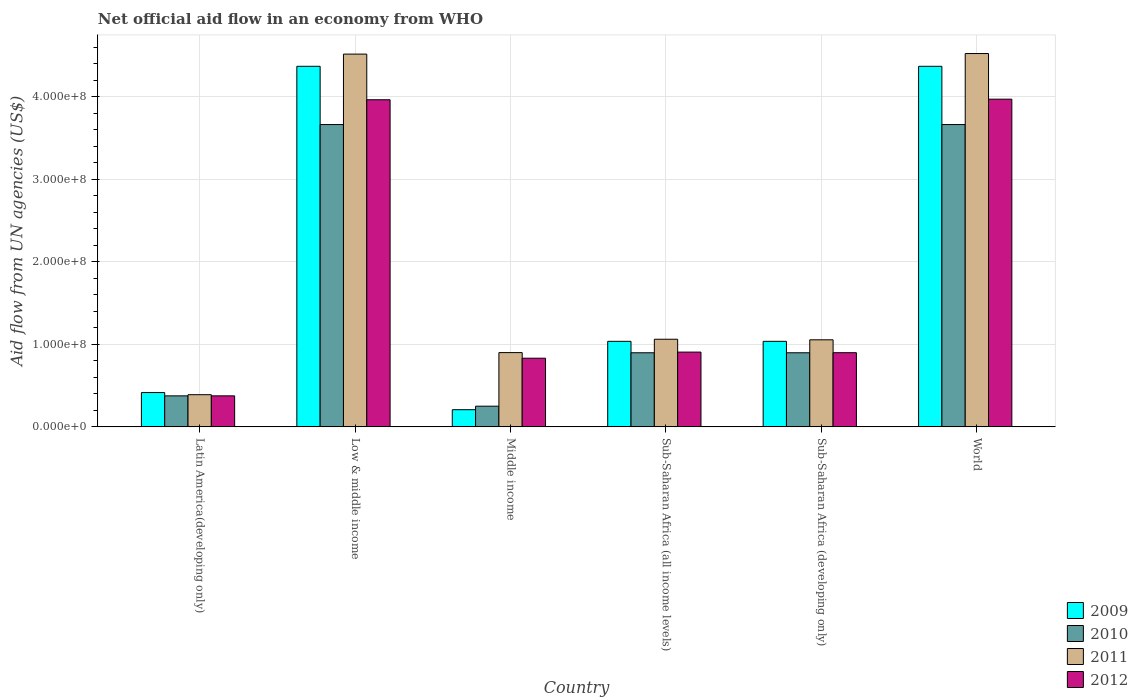How many different coloured bars are there?
Provide a short and direct response. 4. How many groups of bars are there?
Provide a succinct answer. 6. Are the number of bars on each tick of the X-axis equal?
Offer a very short reply. Yes. How many bars are there on the 4th tick from the left?
Make the answer very short. 4. In how many cases, is the number of bars for a given country not equal to the number of legend labels?
Give a very brief answer. 0. What is the net official aid flow in 2011 in Sub-Saharan Africa (developing only)?
Give a very brief answer. 1.05e+08. Across all countries, what is the maximum net official aid flow in 2009?
Give a very brief answer. 4.37e+08. Across all countries, what is the minimum net official aid flow in 2011?
Keep it short and to the point. 3.90e+07. In which country was the net official aid flow in 2011 maximum?
Offer a very short reply. World. In which country was the net official aid flow in 2010 minimum?
Offer a terse response. Middle income. What is the total net official aid flow in 2012 in the graph?
Give a very brief answer. 1.09e+09. What is the difference between the net official aid flow in 2012 in Latin America(developing only) and that in World?
Provide a succinct answer. -3.59e+08. What is the difference between the net official aid flow in 2012 in World and the net official aid flow in 2010 in Sub-Saharan Africa (developing only)?
Your answer should be very brief. 3.07e+08. What is the average net official aid flow in 2011 per country?
Offer a very short reply. 2.07e+08. What is the difference between the net official aid flow of/in 2009 and net official aid flow of/in 2012 in Sub-Saharan Africa (developing only)?
Your response must be concise. 1.38e+07. What is the ratio of the net official aid flow in 2012 in Latin America(developing only) to that in Sub-Saharan Africa (all income levels)?
Make the answer very short. 0.41. What is the difference between the highest and the second highest net official aid flow in 2012?
Ensure brevity in your answer.  3.06e+08. What is the difference between the highest and the lowest net official aid flow in 2010?
Your answer should be very brief. 3.41e+08. Is the sum of the net official aid flow in 2011 in Sub-Saharan Africa (developing only) and World greater than the maximum net official aid flow in 2012 across all countries?
Give a very brief answer. Yes. What does the 3rd bar from the left in Middle income represents?
Keep it short and to the point. 2011. What does the 1st bar from the right in Latin America(developing only) represents?
Make the answer very short. 2012. Is it the case that in every country, the sum of the net official aid flow in 2011 and net official aid flow in 2012 is greater than the net official aid flow in 2010?
Provide a succinct answer. Yes. How many countries are there in the graph?
Keep it short and to the point. 6. Are the values on the major ticks of Y-axis written in scientific E-notation?
Your answer should be very brief. Yes. What is the title of the graph?
Offer a very short reply. Net official aid flow in an economy from WHO. Does "1999" appear as one of the legend labels in the graph?
Provide a succinct answer. No. What is the label or title of the Y-axis?
Offer a very short reply. Aid flow from UN agencies (US$). What is the Aid flow from UN agencies (US$) in 2009 in Latin America(developing only)?
Give a very brief answer. 4.16e+07. What is the Aid flow from UN agencies (US$) in 2010 in Latin America(developing only)?
Provide a short and direct response. 3.76e+07. What is the Aid flow from UN agencies (US$) of 2011 in Latin America(developing only)?
Keep it short and to the point. 3.90e+07. What is the Aid flow from UN agencies (US$) in 2012 in Latin America(developing only)?
Provide a short and direct response. 3.76e+07. What is the Aid flow from UN agencies (US$) in 2009 in Low & middle income?
Keep it short and to the point. 4.37e+08. What is the Aid flow from UN agencies (US$) of 2010 in Low & middle income?
Make the answer very short. 3.66e+08. What is the Aid flow from UN agencies (US$) of 2011 in Low & middle income?
Your response must be concise. 4.52e+08. What is the Aid flow from UN agencies (US$) in 2012 in Low & middle income?
Ensure brevity in your answer.  3.96e+08. What is the Aid flow from UN agencies (US$) in 2009 in Middle income?
Your answer should be very brief. 2.08e+07. What is the Aid flow from UN agencies (US$) in 2010 in Middle income?
Offer a terse response. 2.51e+07. What is the Aid flow from UN agencies (US$) in 2011 in Middle income?
Offer a terse response. 9.00e+07. What is the Aid flow from UN agencies (US$) of 2012 in Middle income?
Your response must be concise. 8.32e+07. What is the Aid flow from UN agencies (US$) in 2009 in Sub-Saharan Africa (all income levels)?
Offer a very short reply. 1.04e+08. What is the Aid flow from UN agencies (US$) of 2010 in Sub-Saharan Africa (all income levels)?
Offer a very short reply. 8.98e+07. What is the Aid flow from UN agencies (US$) in 2011 in Sub-Saharan Africa (all income levels)?
Ensure brevity in your answer.  1.06e+08. What is the Aid flow from UN agencies (US$) in 2012 in Sub-Saharan Africa (all income levels)?
Your answer should be compact. 9.06e+07. What is the Aid flow from UN agencies (US$) of 2009 in Sub-Saharan Africa (developing only)?
Offer a terse response. 1.04e+08. What is the Aid flow from UN agencies (US$) of 2010 in Sub-Saharan Africa (developing only)?
Give a very brief answer. 8.98e+07. What is the Aid flow from UN agencies (US$) in 2011 in Sub-Saharan Africa (developing only)?
Make the answer very short. 1.05e+08. What is the Aid flow from UN agencies (US$) in 2012 in Sub-Saharan Africa (developing only)?
Make the answer very short. 8.98e+07. What is the Aid flow from UN agencies (US$) in 2009 in World?
Keep it short and to the point. 4.37e+08. What is the Aid flow from UN agencies (US$) in 2010 in World?
Provide a succinct answer. 3.66e+08. What is the Aid flow from UN agencies (US$) of 2011 in World?
Provide a succinct answer. 4.52e+08. What is the Aid flow from UN agencies (US$) of 2012 in World?
Make the answer very short. 3.97e+08. Across all countries, what is the maximum Aid flow from UN agencies (US$) in 2009?
Keep it short and to the point. 4.37e+08. Across all countries, what is the maximum Aid flow from UN agencies (US$) of 2010?
Ensure brevity in your answer.  3.66e+08. Across all countries, what is the maximum Aid flow from UN agencies (US$) in 2011?
Offer a very short reply. 4.52e+08. Across all countries, what is the maximum Aid flow from UN agencies (US$) of 2012?
Keep it short and to the point. 3.97e+08. Across all countries, what is the minimum Aid flow from UN agencies (US$) in 2009?
Offer a terse response. 2.08e+07. Across all countries, what is the minimum Aid flow from UN agencies (US$) in 2010?
Offer a terse response. 2.51e+07. Across all countries, what is the minimum Aid flow from UN agencies (US$) in 2011?
Your response must be concise. 3.90e+07. Across all countries, what is the minimum Aid flow from UN agencies (US$) in 2012?
Provide a succinct answer. 3.76e+07. What is the total Aid flow from UN agencies (US$) in 2009 in the graph?
Provide a short and direct response. 1.14e+09. What is the total Aid flow from UN agencies (US$) of 2010 in the graph?
Your response must be concise. 9.75e+08. What is the total Aid flow from UN agencies (US$) in 2011 in the graph?
Your response must be concise. 1.24e+09. What is the total Aid flow from UN agencies (US$) in 2012 in the graph?
Keep it short and to the point. 1.09e+09. What is the difference between the Aid flow from UN agencies (US$) of 2009 in Latin America(developing only) and that in Low & middle income?
Offer a terse response. -3.95e+08. What is the difference between the Aid flow from UN agencies (US$) in 2010 in Latin America(developing only) and that in Low & middle income?
Give a very brief answer. -3.29e+08. What is the difference between the Aid flow from UN agencies (US$) in 2011 in Latin America(developing only) and that in Low & middle income?
Your answer should be compact. -4.13e+08. What is the difference between the Aid flow from UN agencies (US$) of 2012 in Latin America(developing only) and that in Low & middle income?
Keep it short and to the point. -3.59e+08. What is the difference between the Aid flow from UN agencies (US$) in 2009 in Latin America(developing only) and that in Middle income?
Ensure brevity in your answer.  2.08e+07. What is the difference between the Aid flow from UN agencies (US$) in 2010 in Latin America(developing only) and that in Middle income?
Offer a terse response. 1.25e+07. What is the difference between the Aid flow from UN agencies (US$) in 2011 in Latin America(developing only) and that in Middle income?
Offer a very short reply. -5.10e+07. What is the difference between the Aid flow from UN agencies (US$) of 2012 in Latin America(developing only) and that in Middle income?
Your answer should be very brief. -4.56e+07. What is the difference between the Aid flow from UN agencies (US$) in 2009 in Latin America(developing only) and that in Sub-Saharan Africa (all income levels)?
Offer a terse response. -6.20e+07. What is the difference between the Aid flow from UN agencies (US$) of 2010 in Latin America(developing only) and that in Sub-Saharan Africa (all income levels)?
Give a very brief answer. -5.22e+07. What is the difference between the Aid flow from UN agencies (US$) of 2011 in Latin America(developing only) and that in Sub-Saharan Africa (all income levels)?
Give a very brief answer. -6.72e+07. What is the difference between the Aid flow from UN agencies (US$) in 2012 in Latin America(developing only) and that in Sub-Saharan Africa (all income levels)?
Provide a succinct answer. -5.30e+07. What is the difference between the Aid flow from UN agencies (US$) in 2009 in Latin America(developing only) and that in Sub-Saharan Africa (developing only)?
Ensure brevity in your answer.  -6.20e+07. What is the difference between the Aid flow from UN agencies (US$) in 2010 in Latin America(developing only) and that in Sub-Saharan Africa (developing only)?
Provide a short and direct response. -5.22e+07. What is the difference between the Aid flow from UN agencies (US$) in 2011 in Latin America(developing only) and that in Sub-Saharan Africa (developing only)?
Your answer should be very brief. -6.65e+07. What is the difference between the Aid flow from UN agencies (US$) of 2012 in Latin America(developing only) and that in Sub-Saharan Africa (developing only)?
Provide a short and direct response. -5.23e+07. What is the difference between the Aid flow from UN agencies (US$) in 2009 in Latin America(developing only) and that in World?
Your answer should be very brief. -3.95e+08. What is the difference between the Aid flow from UN agencies (US$) in 2010 in Latin America(developing only) and that in World?
Provide a short and direct response. -3.29e+08. What is the difference between the Aid flow from UN agencies (US$) of 2011 in Latin America(developing only) and that in World?
Your answer should be compact. -4.13e+08. What is the difference between the Aid flow from UN agencies (US$) in 2012 in Latin America(developing only) and that in World?
Your response must be concise. -3.59e+08. What is the difference between the Aid flow from UN agencies (US$) in 2009 in Low & middle income and that in Middle income?
Provide a short and direct response. 4.16e+08. What is the difference between the Aid flow from UN agencies (US$) of 2010 in Low & middle income and that in Middle income?
Your answer should be compact. 3.41e+08. What is the difference between the Aid flow from UN agencies (US$) of 2011 in Low & middle income and that in Middle income?
Provide a short and direct response. 3.62e+08. What is the difference between the Aid flow from UN agencies (US$) in 2012 in Low & middle income and that in Middle income?
Provide a short and direct response. 3.13e+08. What is the difference between the Aid flow from UN agencies (US$) in 2009 in Low & middle income and that in Sub-Saharan Africa (all income levels)?
Provide a short and direct response. 3.33e+08. What is the difference between the Aid flow from UN agencies (US$) in 2010 in Low & middle income and that in Sub-Saharan Africa (all income levels)?
Keep it short and to the point. 2.76e+08. What is the difference between the Aid flow from UN agencies (US$) of 2011 in Low & middle income and that in Sub-Saharan Africa (all income levels)?
Ensure brevity in your answer.  3.45e+08. What is the difference between the Aid flow from UN agencies (US$) of 2012 in Low & middle income and that in Sub-Saharan Africa (all income levels)?
Provide a succinct answer. 3.06e+08. What is the difference between the Aid flow from UN agencies (US$) in 2009 in Low & middle income and that in Sub-Saharan Africa (developing only)?
Provide a succinct answer. 3.33e+08. What is the difference between the Aid flow from UN agencies (US$) of 2010 in Low & middle income and that in Sub-Saharan Africa (developing only)?
Your response must be concise. 2.76e+08. What is the difference between the Aid flow from UN agencies (US$) in 2011 in Low & middle income and that in Sub-Saharan Africa (developing only)?
Provide a succinct answer. 3.46e+08. What is the difference between the Aid flow from UN agencies (US$) of 2012 in Low & middle income and that in Sub-Saharan Africa (developing only)?
Your response must be concise. 3.06e+08. What is the difference between the Aid flow from UN agencies (US$) in 2009 in Low & middle income and that in World?
Your answer should be compact. 0. What is the difference between the Aid flow from UN agencies (US$) of 2010 in Low & middle income and that in World?
Ensure brevity in your answer.  0. What is the difference between the Aid flow from UN agencies (US$) in 2011 in Low & middle income and that in World?
Offer a very short reply. -6.70e+05. What is the difference between the Aid flow from UN agencies (US$) of 2012 in Low & middle income and that in World?
Give a very brief answer. -7.20e+05. What is the difference between the Aid flow from UN agencies (US$) in 2009 in Middle income and that in Sub-Saharan Africa (all income levels)?
Your response must be concise. -8.28e+07. What is the difference between the Aid flow from UN agencies (US$) in 2010 in Middle income and that in Sub-Saharan Africa (all income levels)?
Keep it short and to the point. -6.47e+07. What is the difference between the Aid flow from UN agencies (US$) of 2011 in Middle income and that in Sub-Saharan Africa (all income levels)?
Your answer should be very brief. -1.62e+07. What is the difference between the Aid flow from UN agencies (US$) of 2012 in Middle income and that in Sub-Saharan Africa (all income levels)?
Your answer should be very brief. -7.39e+06. What is the difference between the Aid flow from UN agencies (US$) in 2009 in Middle income and that in Sub-Saharan Africa (developing only)?
Give a very brief answer. -8.28e+07. What is the difference between the Aid flow from UN agencies (US$) of 2010 in Middle income and that in Sub-Saharan Africa (developing only)?
Offer a very short reply. -6.47e+07. What is the difference between the Aid flow from UN agencies (US$) of 2011 in Middle income and that in Sub-Saharan Africa (developing only)?
Your response must be concise. -1.55e+07. What is the difference between the Aid flow from UN agencies (US$) of 2012 in Middle income and that in Sub-Saharan Africa (developing only)?
Your answer should be compact. -6.67e+06. What is the difference between the Aid flow from UN agencies (US$) in 2009 in Middle income and that in World?
Give a very brief answer. -4.16e+08. What is the difference between the Aid flow from UN agencies (US$) of 2010 in Middle income and that in World?
Your answer should be compact. -3.41e+08. What is the difference between the Aid flow from UN agencies (US$) of 2011 in Middle income and that in World?
Provide a succinct answer. -3.62e+08. What is the difference between the Aid flow from UN agencies (US$) of 2012 in Middle income and that in World?
Make the answer very short. -3.14e+08. What is the difference between the Aid flow from UN agencies (US$) in 2009 in Sub-Saharan Africa (all income levels) and that in Sub-Saharan Africa (developing only)?
Provide a short and direct response. 0. What is the difference between the Aid flow from UN agencies (US$) in 2011 in Sub-Saharan Africa (all income levels) and that in Sub-Saharan Africa (developing only)?
Provide a short and direct response. 6.70e+05. What is the difference between the Aid flow from UN agencies (US$) in 2012 in Sub-Saharan Africa (all income levels) and that in Sub-Saharan Africa (developing only)?
Ensure brevity in your answer.  7.20e+05. What is the difference between the Aid flow from UN agencies (US$) in 2009 in Sub-Saharan Africa (all income levels) and that in World?
Your response must be concise. -3.33e+08. What is the difference between the Aid flow from UN agencies (US$) of 2010 in Sub-Saharan Africa (all income levels) and that in World?
Ensure brevity in your answer.  -2.76e+08. What is the difference between the Aid flow from UN agencies (US$) of 2011 in Sub-Saharan Africa (all income levels) and that in World?
Your response must be concise. -3.46e+08. What is the difference between the Aid flow from UN agencies (US$) of 2012 in Sub-Saharan Africa (all income levels) and that in World?
Provide a short and direct response. -3.06e+08. What is the difference between the Aid flow from UN agencies (US$) of 2009 in Sub-Saharan Africa (developing only) and that in World?
Your response must be concise. -3.33e+08. What is the difference between the Aid flow from UN agencies (US$) of 2010 in Sub-Saharan Africa (developing only) and that in World?
Give a very brief answer. -2.76e+08. What is the difference between the Aid flow from UN agencies (US$) of 2011 in Sub-Saharan Africa (developing only) and that in World?
Your answer should be very brief. -3.47e+08. What is the difference between the Aid flow from UN agencies (US$) of 2012 in Sub-Saharan Africa (developing only) and that in World?
Give a very brief answer. -3.07e+08. What is the difference between the Aid flow from UN agencies (US$) of 2009 in Latin America(developing only) and the Aid flow from UN agencies (US$) of 2010 in Low & middle income?
Provide a succinct answer. -3.25e+08. What is the difference between the Aid flow from UN agencies (US$) in 2009 in Latin America(developing only) and the Aid flow from UN agencies (US$) in 2011 in Low & middle income?
Your answer should be compact. -4.10e+08. What is the difference between the Aid flow from UN agencies (US$) in 2009 in Latin America(developing only) and the Aid flow from UN agencies (US$) in 2012 in Low & middle income?
Your answer should be very brief. -3.55e+08. What is the difference between the Aid flow from UN agencies (US$) in 2010 in Latin America(developing only) and the Aid flow from UN agencies (US$) in 2011 in Low & middle income?
Give a very brief answer. -4.14e+08. What is the difference between the Aid flow from UN agencies (US$) in 2010 in Latin America(developing only) and the Aid flow from UN agencies (US$) in 2012 in Low & middle income?
Your answer should be compact. -3.59e+08. What is the difference between the Aid flow from UN agencies (US$) of 2011 in Latin America(developing only) and the Aid flow from UN agencies (US$) of 2012 in Low & middle income?
Make the answer very short. -3.57e+08. What is the difference between the Aid flow from UN agencies (US$) of 2009 in Latin America(developing only) and the Aid flow from UN agencies (US$) of 2010 in Middle income?
Offer a very short reply. 1.65e+07. What is the difference between the Aid flow from UN agencies (US$) of 2009 in Latin America(developing only) and the Aid flow from UN agencies (US$) of 2011 in Middle income?
Keep it short and to the point. -4.84e+07. What is the difference between the Aid flow from UN agencies (US$) of 2009 in Latin America(developing only) and the Aid flow from UN agencies (US$) of 2012 in Middle income?
Your answer should be very brief. -4.16e+07. What is the difference between the Aid flow from UN agencies (US$) in 2010 in Latin America(developing only) and the Aid flow from UN agencies (US$) in 2011 in Middle income?
Ensure brevity in your answer.  -5.24e+07. What is the difference between the Aid flow from UN agencies (US$) of 2010 in Latin America(developing only) and the Aid flow from UN agencies (US$) of 2012 in Middle income?
Make the answer very short. -4.56e+07. What is the difference between the Aid flow from UN agencies (US$) of 2011 in Latin America(developing only) and the Aid flow from UN agencies (US$) of 2012 in Middle income?
Keep it short and to the point. -4.42e+07. What is the difference between the Aid flow from UN agencies (US$) in 2009 in Latin America(developing only) and the Aid flow from UN agencies (US$) in 2010 in Sub-Saharan Africa (all income levels)?
Your response must be concise. -4.82e+07. What is the difference between the Aid flow from UN agencies (US$) of 2009 in Latin America(developing only) and the Aid flow from UN agencies (US$) of 2011 in Sub-Saharan Africa (all income levels)?
Keep it short and to the point. -6.46e+07. What is the difference between the Aid flow from UN agencies (US$) of 2009 in Latin America(developing only) and the Aid flow from UN agencies (US$) of 2012 in Sub-Saharan Africa (all income levels)?
Offer a terse response. -4.90e+07. What is the difference between the Aid flow from UN agencies (US$) in 2010 in Latin America(developing only) and the Aid flow from UN agencies (US$) in 2011 in Sub-Saharan Africa (all income levels)?
Your response must be concise. -6.86e+07. What is the difference between the Aid flow from UN agencies (US$) in 2010 in Latin America(developing only) and the Aid flow from UN agencies (US$) in 2012 in Sub-Saharan Africa (all income levels)?
Offer a very short reply. -5.30e+07. What is the difference between the Aid flow from UN agencies (US$) in 2011 in Latin America(developing only) and the Aid flow from UN agencies (US$) in 2012 in Sub-Saharan Africa (all income levels)?
Give a very brief answer. -5.16e+07. What is the difference between the Aid flow from UN agencies (US$) of 2009 in Latin America(developing only) and the Aid flow from UN agencies (US$) of 2010 in Sub-Saharan Africa (developing only)?
Keep it short and to the point. -4.82e+07. What is the difference between the Aid flow from UN agencies (US$) in 2009 in Latin America(developing only) and the Aid flow from UN agencies (US$) in 2011 in Sub-Saharan Africa (developing only)?
Make the answer very short. -6.39e+07. What is the difference between the Aid flow from UN agencies (US$) in 2009 in Latin America(developing only) and the Aid flow from UN agencies (US$) in 2012 in Sub-Saharan Africa (developing only)?
Keep it short and to the point. -4.83e+07. What is the difference between the Aid flow from UN agencies (US$) of 2010 in Latin America(developing only) and the Aid flow from UN agencies (US$) of 2011 in Sub-Saharan Africa (developing only)?
Offer a terse response. -6.79e+07. What is the difference between the Aid flow from UN agencies (US$) in 2010 in Latin America(developing only) and the Aid flow from UN agencies (US$) in 2012 in Sub-Saharan Africa (developing only)?
Give a very brief answer. -5.23e+07. What is the difference between the Aid flow from UN agencies (US$) in 2011 in Latin America(developing only) and the Aid flow from UN agencies (US$) in 2012 in Sub-Saharan Africa (developing only)?
Make the answer very short. -5.09e+07. What is the difference between the Aid flow from UN agencies (US$) in 2009 in Latin America(developing only) and the Aid flow from UN agencies (US$) in 2010 in World?
Provide a short and direct response. -3.25e+08. What is the difference between the Aid flow from UN agencies (US$) of 2009 in Latin America(developing only) and the Aid flow from UN agencies (US$) of 2011 in World?
Your answer should be compact. -4.11e+08. What is the difference between the Aid flow from UN agencies (US$) of 2009 in Latin America(developing only) and the Aid flow from UN agencies (US$) of 2012 in World?
Offer a very short reply. -3.55e+08. What is the difference between the Aid flow from UN agencies (US$) of 2010 in Latin America(developing only) and the Aid flow from UN agencies (US$) of 2011 in World?
Offer a terse response. -4.15e+08. What is the difference between the Aid flow from UN agencies (US$) in 2010 in Latin America(developing only) and the Aid flow from UN agencies (US$) in 2012 in World?
Offer a very short reply. -3.59e+08. What is the difference between the Aid flow from UN agencies (US$) of 2011 in Latin America(developing only) and the Aid flow from UN agencies (US$) of 2012 in World?
Offer a terse response. -3.58e+08. What is the difference between the Aid flow from UN agencies (US$) of 2009 in Low & middle income and the Aid flow from UN agencies (US$) of 2010 in Middle income?
Your answer should be compact. 4.12e+08. What is the difference between the Aid flow from UN agencies (US$) of 2009 in Low & middle income and the Aid flow from UN agencies (US$) of 2011 in Middle income?
Your response must be concise. 3.47e+08. What is the difference between the Aid flow from UN agencies (US$) in 2009 in Low & middle income and the Aid flow from UN agencies (US$) in 2012 in Middle income?
Provide a succinct answer. 3.54e+08. What is the difference between the Aid flow from UN agencies (US$) in 2010 in Low & middle income and the Aid flow from UN agencies (US$) in 2011 in Middle income?
Make the answer very short. 2.76e+08. What is the difference between the Aid flow from UN agencies (US$) of 2010 in Low & middle income and the Aid flow from UN agencies (US$) of 2012 in Middle income?
Ensure brevity in your answer.  2.83e+08. What is the difference between the Aid flow from UN agencies (US$) of 2011 in Low & middle income and the Aid flow from UN agencies (US$) of 2012 in Middle income?
Offer a terse response. 3.68e+08. What is the difference between the Aid flow from UN agencies (US$) in 2009 in Low & middle income and the Aid flow from UN agencies (US$) in 2010 in Sub-Saharan Africa (all income levels)?
Make the answer very short. 3.47e+08. What is the difference between the Aid flow from UN agencies (US$) of 2009 in Low & middle income and the Aid flow from UN agencies (US$) of 2011 in Sub-Saharan Africa (all income levels)?
Ensure brevity in your answer.  3.31e+08. What is the difference between the Aid flow from UN agencies (US$) in 2009 in Low & middle income and the Aid flow from UN agencies (US$) in 2012 in Sub-Saharan Africa (all income levels)?
Ensure brevity in your answer.  3.46e+08. What is the difference between the Aid flow from UN agencies (US$) in 2010 in Low & middle income and the Aid flow from UN agencies (US$) in 2011 in Sub-Saharan Africa (all income levels)?
Your answer should be very brief. 2.60e+08. What is the difference between the Aid flow from UN agencies (US$) of 2010 in Low & middle income and the Aid flow from UN agencies (US$) of 2012 in Sub-Saharan Africa (all income levels)?
Give a very brief answer. 2.76e+08. What is the difference between the Aid flow from UN agencies (US$) of 2011 in Low & middle income and the Aid flow from UN agencies (US$) of 2012 in Sub-Saharan Africa (all income levels)?
Ensure brevity in your answer.  3.61e+08. What is the difference between the Aid flow from UN agencies (US$) in 2009 in Low & middle income and the Aid flow from UN agencies (US$) in 2010 in Sub-Saharan Africa (developing only)?
Provide a short and direct response. 3.47e+08. What is the difference between the Aid flow from UN agencies (US$) of 2009 in Low & middle income and the Aid flow from UN agencies (US$) of 2011 in Sub-Saharan Africa (developing only)?
Keep it short and to the point. 3.31e+08. What is the difference between the Aid flow from UN agencies (US$) in 2009 in Low & middle income and the Aid flow from UN agencies (US$) in 2012 in Sub-Saharan Africa (developing only)?
Make the answer very short. 3.47e+08. What is the difference between the Aid flow from UN agencies (US$) in 2010 in Low & middle income and the Aid flow from UN agencies (US$) in 2011 in Sub-Saharan Africa (developing only)?
Ensure brevity in your answer.  2.61e+08. What is the difference between the Aid flow from UN agencies (US$) in 2010 in Low & middle income and the Aid flow from UN agencies (US$) in 2012 in Sub-Saharan Africa (developing only)?
Offer a very short reply. 2.76e+08. What is the difference between the Aid flow from UN agencies (US$) of 2011 in Low & middle income and the Aid flow from UN agencies (US$) of 2012 in Sub-Saharan Africa (developing only)?
Ensure brevity in your answer.  3.62e+08. What is the difference between the Aid flow from UN agencies (US$) of 2009 in Low & middle income and the Aid flow from UN agencies (US$) of 2010 in World?
Offer a terse response. 7.06e+07. What is the difference between the Aid flow from UN agencies (US$) of 2009 in Low & middle income and the Aid flow from UN agencies (US$) of 2011 in World?
Your answer should be very brief. -1.55e+07. What is the difference between the Aid flow from UN agencies (US$) in 2009 in Low & middle income and the Aid flow from UN agencies (US$) in 2012 in World?
Provide a succinct answer. 3.98e+07. What is the difference between the Aid flow from UN agencies (US$) of 2010 in Low & middle income and the Aid flow from UN agencies (US$) of 2011 in World?
Your answer should be very brief. -8.60e+07. What is the difference between the Aid flow from UN agencies (US$) in 2010 in Low & middle income and the Aid flow from UN agencies (US$) in 2012 in World?
Your answer should be very brief. -3.08e+07. What is the difference between the Aid flow from UN agencies (US$) in 2011 in Low & middle income and the Aid flow from UN agencies (US$) in 2012 in World?
Ensure brevity in your answer.  5.46e+07. What is the difference between the Aid flow from UN agencies (US$) of 2009 in Middle income and the Aid flow from UN agencies (US$) of 2010 in Sub-Saharan Africa (all income levels)?
Provide a succinct answer. -6.90e+07. What is the difference between the Aid flow from UN agencies (US$) of 2009 in Middle income and the Aid flow from UN agencies (US$) of 2011 in Sub-Saharan Africa (all income levels)?
Provide a succinct answer. -8.54e+07. What is the difference between the Aid flow from UN agencies (US$) of 2009 in Middle income and the Aid flow from UN agencies (US$) of 2012 in Sub-Saharan Africa (all income levels)?
Keep it short and to the point. -6.98e+07. What is the difference between the Aid flow from UN agencies (US$) of 2010 in Middle income and the Aid flow from UN agencies (US$) of 2011 in Sub-Saharan Africa (all income levels)?
Make the answer very short. -8.11e+07. What is the difference between the Aid flow from UN agencies (US$) of 2010 in Middle income and the Aid flow from UN agencies (US$) of 2012 in Sub-Saharan Africa (all income levels)?
Keep it short and to the point. -6.55e+07. What is the difference between the Aid flow from UN agencies (US$) of 2011 in Middle income and the Aid flow from UN agencies (US$) of 2012 in Sub-Saharan Africa (all income levels)?
Keep it short and to the point. -5.90e+05. What is the difference between the Aid flow from UN agencies (US$) in 2009 in Middle income and the Aid flow from UN agencies (US$) in 2010 in Sub-Saharan Africa (developing only)?
Keep it short and to the point. -6.90e+07. What is the difference between the Aid flow from UN agencies (US$) in 2009 in Middle income and the Aid flow from UN agencies (US$) in 2011 in Sub-Saharan Africa (developing only)?
Your response must be concise. -8.47e+07. What is the difference between the Aid flow from UN agencies (US$) of 2009 in Middle income and the Aid flow from UN agencies (US$) of 2012 in Sub-Saharan Africa (developing only)?
Keep it short and to the point. -6.90e+07. What is the difference between the Aid flow from UN agencies (US$) of 2010 in Middle income and the Aid flow from UN agencies (US$) of 2011 in Sub-Saharan Africa (developing only)?
Offer a very short reply. -8.04e+07. What is the difference between the Aid flow from UN agencies (US$) of 2010 in Middle income and the Aid flow from UN agencies (US$) of 2012 in Sub-Saharan Africa (developing only)?
Your answer should be compact. -6.48e+07. What is the difference between the Aid flow from UN agencies (US$) of 2009 in Middle income and the Aid flow from UN agencies (US$) of 2010 in World?
Make the answer very short. -3.45e+08. What is the difference between the Aid flow from UN agencies (US$) of 2009 in Middle income and the Aid flow from UN agencies (US$) of 2011 in World?
Offer a very short reply. -4.31e+08. What is the difference between the Aid flow from UN agencies (US$) of 2009 in Middle income and the Aid flow from UN agencies (US$) of 2012 in World?
Provide a short and direct response. -3.76e+08. What is the difference between the Aid flow from UN agencies (US$) of 2010 in Middle income and the Aid flow from UN agencies (US$) of 2011 in World?
Provide a short and direct response. -4.27e+08. What is the difference between the Aid flow from UN agencies (US$) in 2010 in Middle income and the Aid flow from UN agencies (US$) in 2012 in World?
Offer a very short reply. -3.72e+08. What is the difference between the Aid flow from UN agencies (US$) in 2011 in Middle income and the Aid flow from UN agencies (US$) in 2012 in World?
Give a very brief answer. -3.07e+08. What is the difference between the Aid flow from UN agencies (US$) of 2009 in Sub-Saharan Africa (all income levels) and the Aid flow from UN agencies (US$) of 2010 in Sub-Saharan Africa (developing only)?
Keep it short and to the point. 1.39e+07. What is the difference between the Aid flow from UN agencies (US$) of 2009 in Sub-Saharan Africa (all income levels) and the Aid flow from UN agencies (US$) of 2011 in Sub-Saharan Africa (developing only)?
Your response must be concise. -1.86e+06. What is the difference between the Aid flow from UN agencies (US$) in 2009 in Sub-Saharan Africa (all income levels) and the Aid flow from UN agencies (US$) in 2012 in Sub-Saharan Africa (developing only)?
Keep it short and to the point. 1.38e+07. What is the difference between the Aid flow from UN agencies (US$) in 2010 in Sub-Saharan Africa (all income levels) and the Aid flow from UN agencies (US$) in 2011 in Sub-Saharan Africa (developing only)?
Your response must be concise. -1.57e+07. What is the difference between the Aid flow from UN agencies (US$) of 2011 in Sub-Saharan Africa (all income levels) and the Aid flow from UN agencies (US$) of 2012 in Sub-Saharan Africa (developing only)?
Your answer should be compact. 1.63e+07. What is the difference between the Aid flow from UN agencies (US$) in 2009 in Sub-Saharan Africa (all income levels) and the Aid flow from UN agencies (US$) in 2010 in World?
Give a very brief answer. -2.63e+08. What is the difference between the Aid flow from UN agencies (US$) of 2009 in Sub-Saharan Africa (all income levels) and the Aid flow from UN agencies (US$) of 2011 in World?
Ensure brevity in your answer.  -3.49e+08. What is the difference between the Aid flow from UN agencies (US$) of 2009 in Sub-Saharan Africa (all income levels) and the Aid flow from UN agencies (US$) of 2012 in World?
Make the answer very short. -2.93e+08. What is the difference between the Aid flow from UN agencies (US$) of 2010 in Sub-Saharan Africa (all income levels) and the Aid flow from UN agencies (US$) of 2011 in World?
Provide a short and direct response. -3.62e+08. What is the difference between the Aid flow from UN agencies (US$) in 2010 in Sub-Saharan Africa (all income levels) and the Aid flow from UN agencies (US$) in 2012 in World?
Your answer should be compact. -3.07e+08. What is the difference between the Aid flow from UN agencies (US$) of 2011 in Sub-Saharan Africa (all income levels) and the Aid flow from UN agencies (US$) of 2012 in World?
Your answer should be very brief. -2.91e+08. What is the difference between the Aid flow from UN agencies (US$) in 2009 in Sub-Saharan Africa (developing only) and the Aid flow from UN agencies (US$) in 2010 in World?
Provide a short and direct response. -2.63e+08. What is the difference between the Aid flow from UN agencies (US$) of 2009 in Sub-Saharan Africa (developing only) and the Aid flow from UN agencies (US$) of 2011 in World?
Make the answer very short. -3.49e+08. What is the difference between the Aid flow from UN agencies (US$) of 2009 in Sub-Saharan Africa (developing only) and the Aid flow from UN agencies (US$) of 2012 in World?
Provide a short and direct response. -2.93e+08. What is the difference between the Aid flow from UN agencies (US$) of 2010 in Sub-Saharan Africa (developing only) and the Aid flow from UN agencies (US$) of 2011 in World?
Offer a terse response. -3.62e+08. What is the difference between the Aid flow from UN agencies (US$) of 2010 in Sub-Saharan Africa (developing only) and the Aid flow from UN agencies (US$) of 2012 in World?
Make the answer very short. -3.07e+08. What is the difference between the Aid flow from UN agencies (US$) in 2011 in Sub-Saharan Africa (developing only) and the Aid flow from UN agencies (US$) in 2012 in World?
Give a very brief answer. -2.92e+08. What is the average Aid flow from UN agencies (US$) of 2009 per country?
Ensure brevity in your answer.  1.91e+08. What is the average Aid flow from UN agencies (US$) of 2010 per country?
Give a very brief answer. 1.62e+08. What is the average Aid flow from UN agencies (US$) in 2011 per country?
Your answer should be very brief. 2.07e+08. What is the average Aid flow from UN agencies (US$) of 2012 per country?
Offer a terse response. 1.82e+08. What is the difference between the Aid flow from UN agencies (US$) in 2009 and Aid flow from UN agencies (US$) in 2010 in Latin America(developing only)?
Your answer should be very brief. 4.01e+06. What is the difference between the Aid flow from UN agencies (US$) in 2009 and Aid flow from UN agencies (US$) in 2011 in Latin America(developing only)?
Your answer should be compact. 2.59e+06. What is the difference between the Aid flow from UN agencies (US$) in 2009 and Aid flow from UN agencies (US$) in 2012 in Latin America(developing only)?
Your answer should be very brief. 3.99e+06. What is the difference between the Aid flow from UN agencies (US$) in 2010 and Aid flow from UN agencies (US$) in 2011 in Latin America(developing only)?
Offer a terse response. -1.42e+06. What is the difference between the Aid flow from UN agencies (US$) in 2010 and Aid flow from UN agencies (US$) in 2012 in Latin America(developing only)?
Your answer should be compact. -2.00e+04. What is the difference between the Aid flow from UN agencies (US$) of 2011 and Aid flow from UN agencies (US$) of 2012 in Latin America(developing only)?
Offer a terse response. 1.40e+06. What is the difference between the Aid flow from UN agencies (US$) in 2009 and Aid flow from UN agencies (US$) in 2010 in Low & middle income?
Ensure brevity in your answer.  7.06e+07. What is the difference between the Aid flow from UN agencies (US$) in 2009 and Aid flow from UN agencies (US$) in 2011 in Low & middle income?
Provide a succinct answer. -1.48e+07. What is the difference between the Aid flow from UN agencies (US$) of 2009 and Aid flow from UN agencies (US$) of 2012 in Low & middle income?
Ensure brevity in your answer.  4.05e+07. What is the difference between the Aid flow from UN agencies (US$) of 2010 and Aid flow from UN agencies (US$) of 2011 in Low & middle income?
Give a very brief answer. -8.54e+07. What is the difference between the Aid flow from UN agencies (US$) of 2010 and Aid flow from UN agencies (US$) of 2012 in Low & middle income?
Your answer should be compact. -3.00e+07. What is the difference between the Aid flow from UN agencies (US$) of 2011 and Aid flow from UN agencies (US$) of 2012 in Low & middle income?
Offer a terse response. 5.53e+07. What is the difference between the Aid flow from UN agencies (US$) in 2009 and Aid flow from UN agencies (US$) in 2010 in Middle income?
Provide a short and direct response. -4.27e+06. What is the difference between the Aid flow from UN agencies (US$) of 2009 and Aid flow from UN agencies (US$) of 2011 in Middle income?
Provide a short and direct response. -6.92e+07. What is the difference between the Aid flow from UN agencies (US$) of 2009 and Aid flow from UN agencies (US$) of 2012 in Middle income?
Your response must be concise. -6.24e+07. What is the difference between the Aid flow from UN agencies (US$) in 2010 and Aid flow from UN agencies (US$) in 2011 in Middle income?
Ensure brevity in your answer.  -6.49e+07. What is the difference between the Aid flow from UN agencies (US$) in 2010 and Aid flow from UN agencies (US$) in 2012 in Middle income?
Provide a succinct answer. -5.81e+07. What is the difference between the Aid flow from UN agencies (US$) of 2011 and Aid flow from UN agencies (US$) of 2012 in Middle income?
Keep it short and to the point. 6.80e+06. What is the difference between the Aid flow from UN agencies (US$) of 2009 and Aid flow from UN agencies (US$) of 2010 in Sub-Saharan Africa (all income levels)?
Your answer should be compact. 1.39e+07. What is the difference between the Aid flow from UN agencies (US$) of 2009 and Aid flow from UN agencies (US$) of 2011 in Sub-Saharan Africa (all income levels)?
Your response must be concise. -2.53e+06. What is the difference between the Aid flow from UN agencies (US$) of 2009 and Aid flow from UN agencies (US$) of 2012 in Sub-Saharan Africa (all income levels)?
Ensure brevity in your answer.  1.30e+07. What is the difference between the Aid flow from UN agencies (US$) in 2010 and Aid flow from UN agencies (US$) in 2011 in Sub-Saharan Africa (all income levels)?
Your answer should be compact. -1.64e+07. What is the difference between the Aid flow from UN agencies (US$) of 2010 and Aid flow from UN agencies (US$) of 2012 in Sub-Saharan Africa (all income levels)?
Your answer should be very brief. -8.10e+05. What is the difference between the Aid flow from UN agencies (US$) of 2011 and Aid flow from UN agencies (US$) of 2012 in Sub-Saharan Africa (all income levels)?
Your response must be concise. 1.56e+07. What is the difference between the Aid flow from UN agencies (US$) of 2009 and Aid flow from UN agencies (US$) of 2010 in Sub-Saharan Africa (developing only)?
Your answer should be compact. 1.39e+07. What is the difference between the Aid flow from UN agencies (US$) in 2009 and Aid flow from UN agencies (US$) in 2011 in Sub-Saharan Africa (developing only)?
Ensure brevity in your answer.  -1.86e+06. What is the difference between the Aid flow from UN agencies (US$) in 2009 and Aid flow from UN agencies (US$) in 2012 in Sub-Saharan Africa (developing only)?
Provide a succinct answer. 1.38e+07. What is the difference between the Aid flow from UN agencies (US$) in 2010 and Aid flow from UN agencies (US$) in 2011 in Sub-Saharan Africa (developing only)?
Your answer should be compact. -1.57e+07. What is the difference between the Aid flow from UN agencies (US$) of 2011 and Aid flow from UN agencies (US$) of 2012 in Sub-Saharan Africa (developing only)?
Provide a succinct answer. 1.56e+07. What is the difference between the Aid flow from UN agencies (US$) in 2009 and Aid flow from UN agencies (US$) in 2010 in World?
Make the answer very short. 7.06e+07. What is the difference between the Aid flow from UN agencies (US$) of 2009 and Aid flow from UN agencies (US$) of 2011 in World?
Your answer should be compact. -1.55e+07. What is the difference between the Aid flow from UN agencies (US$) of 2009 and Aid flow from UN agencies (US$) of 2012 in World?
Give a very brief answer. 3.98e+07. What is the difference between the Aid flow from UN agencies (US$) in 2010 and Aid flow from UN agencies (US$) in 2011 in World?
Your answer should be very brief. -8.60e+07. What is the difference between the Aid flow from UN agencies (US$) in 2010 and Aid flow from UN agencies (US$) in 2012 in World?
Your answer should be compact. -3.08e+07. What is the difference between the Aid flow from UN agencies (US$) of 2011 and Aid flow from UN agencies (US$) of 2012 in World?
Provide a short and direct response. 5.53e+07. What is the ratio of the Aid flow from UN agencies (US$) of 2009 in Latin America(developing only) to that in Low & middle income?
Make the answer very short. 0.1. What is the ratio of the Aid flow from UN agencies (US$) in 2010 in Latin America(developing only) to that in Low & middle income?
Give a very brief answer. 0.1. What is the ratio of the Aid flow from UN agencies (US$) in 2011 in Latin America(developing only) to that in Low & middle income?
Offer a very short reply. 0.09. What is the ratio of the Aid flow from UN agencies (US$) in 2012 in Latin America(developing only) to that in Low & middle income?
Provide a succinct answer. 0.09. What is the ratio of the Aid flow from UN agencies (US$) of 2009 in Latin America(developing only) to that in Middle income?
Offer a terse response. 2. What is the ratio of the Aid flow from UN agencies (US$) in 2010 in Latin America(developing only) to that in Middle income?
Offer a terse response. 1.5. What is the ratio of the Aid flow from UN agencies (US$) in 2011 in Latin America(developing only) to that in Middle income?
Make the answer very short. 0.43. What is the ratio of the Aid flow from UN agencies (US$) in 2012 in Latin America(developing only) to that in Middle income?
Provide a short and direct response. 0.45. What is the ratio of the Aid flow from UN agencies (US$) in 2009 in Latin America(developing only) to that in Sub-Saharan Africa (all income levels)?
Offer a terse response. 0.4. What is the ratio of the Aid flow from UN agencies (US$) in 2010 in Latin America(developing only) to that in Sub-Saharan Africa (all income levels)?
Keep it short and to the point. 0.42. What is the ratio of the Aid flow from UN agencies (US$) of 2011 in Latin America(developing only) to that in Sub-Saharan Africa (all income levels)?
Give a very brief answer. 0.37. What is the ratio of the Aid flow from UN agencies (US$) of 2012 in Latin America(developing only) to that in Sub-Saharan Africa (all income levels)?
Provide a succinct answer. 0.41. What is the ratio of the Aid flow from UN agencies (US$) of 2009 in Latin America(developing only) to that in Sub-Saharan Africa (developing only)?
Ensure brevity in your answer.  0.4. What is the ratio of the Aid flow from UN agencies (US$) of 2010 in Latin America(developing only) to that in Sub-Saharan Africa (developing only)?
Provide a succinct answer. 0.42. What is the ratio of the Aid flow from UN agencies (US$) in 2011 in Latin America(developing only) to that in Sub-Saharan Africa (developing only)?
Provide a succinct answer. 0.37. What is the ratio of the Aid flow from UN agencies (US$) of 2012 in Latin America(developing only) to that in Sub-Saharan Africa (developing only)?
Your answer should be compact. 0.42. What is the ratio of the Aid flow from UN agencies (US$) of 2009 in Latin America(developing only) to that in World?
Make the answer very short. 0.1. What is the ratio of the Aid flow from UN agencies (US$) in 2010 in Latin America(developing only) to that in World?
Ensure brevity in your answer.  0.1. What is the ratio of the Aid flow from UN agencies (US$) of 2011 in Latin America(developing only) to that in World?
Offer a terse response. 0.09. What is the ratio of the Aid flow from UN agencies (US$) of 2012 in Latin America(developing only) to that in World?
Provide a short and direct response. 0.09. What is the ratio of the Aid flow from UN agencies (US$) of 2009 in Low & middle income to that in Middle income?
Your answer should be very brief. 21. What is the ratio of the Aid flow from UN agencies (US$) in 2010 in Low & middle income to that in Middle income?
Make the answer very short. 14.61. What is the ratio of the Aid flow from UN agencies (US$) in 2011 in Low & middle income to that in Middle income?
Your answer should be very brief. 5.02. What is the ratio of the Aid flow from UN agencies (US$) of 2012 in Low & middle income to that in Middle income?
Your answer should be very brief. 4.76. What is the ratio of the Aid flow from UN agencies (US$) of 2009 in Low & middle income to that in Sub-Saharan Africa (all income levels)?
Provide a short and direct response. 4.22. What is the ratio of the Aid flow from UN agencies (US$) of 2010 in Low & middle income to that in Sub-Saharan Africa (all income levels)?
Ensure brevity in your answer.  4.08. What is the ratio of the Aid flow from UN agencies (US$) of 2011 in Low & middle income to that in Sub-Saharan Africa (all income levels)?
Make the answer very short. 4.25. What is the ratio of the Aid flow from UN agencies (US$) in 2012 in Low & middle income to that in Sub-Saharan Africa (all income levels)?
Your answer should be compact. 4.38. What is the ratio of the Aid flow from UN agencies (US$) in 2009 in Low & middle income to that in Sub-Saharan Africa (developing only)?
Give a very brief answer. 4.22. What is the ratio of the Aid flow from UN agencies (US$) in 2010 in Low & middle income to that in Sub-Saharan Africa (developing only)?
Ensure brevity in your answer.  4.08. What is the ratio of the Aid flow from UN agencies (US$) in 2011 in Low & middle income to that in Sub-Saharan Africa (developing only)?
Make the answer very short. 4.28. What is the ratio of the Aid flow from UN agencies (US$) in 2012 in Low & middle income to that in Sub-Saharan Africa (developing only)?
Offer a terse response. 4.41. What is the ratio of the Aid flow from UN agencies (US$) in 2009 in Low & middle income to that in World?
Ensure brevity in your answer.  1. What is the ratio of the Aid flow from UN agencies (US$) in 2011 in Low & middle income to that in World?
Make the answer very short. 1. What is the ratio of the Aid flow from UN agencies (US$) of 2012 in Low & middle income to that in World?
Offer a terse response. 1. What is the ratio of the Aid flow from UN agencies (US$) in 2009 in Middle income to that in Sub-Saharan Africa (all income levels)?
Give a very brief answer. 0.2. What is the ratio of the Aid flow from UN agencies (US$) of 2010 in Middle income to that in Sub-Saharan Africa (all income levels)?
Give a very brief answer. 0.28. What is the ratio of the Aid flow from UN agencies (US$) of 2011 in Middle income to that in Sub-Saharan Africa (all income levels)?
Provide a succinct answer. 0.85. What is the ratio of the Aid flow from UN agencies (US$) in 2012 in Middle income to that in Sub-Saharan Africa (all income levels)?
Offer a very short reply. 0.92. What is the ratio of the Aid flow from UN agencies (US$) in 2009 in Middle income to that in Sub-Saharan Africa (developing only)?
Offer a terse response. 0.2. What is the ratio of the Aid flow from UN agencies (US$) of 2010 in Middle income to that in Sub-Saharan Africa (developing only)?
Offer a terse response. 0.28. What is the ratio of the Aid flow from UN agencies (US$) in 2011 in Middle income to that in Sub-Saharan Africa (developing only)?
Make the answer very short. 0.85. What is the ratio of the Aid flow from UN agencies (US$) in 2012 in Middle income to that in Sub-Saharan Africa (developing only)?
Provide a short and direct response. 0.93. What is the ratio of the Aid flow from UN agencies (US$) in 2009 in Middle income to that in World?
Make the answer very short. 0.05. What is the ratio of the Aid flow from UN agencies (US$) in 2010 in Middle income to that in World?
Ensure brevity in your answer.  0.07. What is the ratio of the Aid flow from UN agencies (US$) of 2011 in Middle income to that in World?
Keep it short and to the point. 0.2. What is the ratio of the Aid flow from UN agencies (US$) of 2012 in Middle income to that in World?
Make the answer very short. 0.21. What is the ratio of the Aid flow from UN agencies (US$) of 2010 in Sub-Saharan Africa (all income levels) to that in Sub-Saharan Africa (developing only)?
Offer a terse response. 1. What is the ratio of the Aid flow from UN agencies (US$) of 2011 in Sub-Saharan Africa (all income levels) to that in Sub-Saharan Africa (developing only)?
Give a very brief answer. 1.01. What is the ratio of the Aid flow from UN agencies (US$) of 2009 in Sub-Saharan Africa (all income levels) to that in World?
Your answer should be very brief. 0.24. What is the ratio of the Aid flow from UN agencies (US$) of 2010 in Sub-Saharan Africa (all income levels) to that in World?
Your response must be concise. 0.25. What is the ratio of the Aid flow from UN agencies (US$) in 2011 in Sub-Saharan Africa (all income levels) to that in World?
Provide a short and direct response. 0.23. What is the ratio of the Aid flow from UN agencies (US$) of 2012 in Sub-Saharan Africa (all income levels) to that in World?
Make the answer very short. 0.23. What is the ratio of the Aid flow from UN agencies (US$) in 2009 in Sub-Saharan Africa (developing only) to that in World?
Make the answer very short. 0.24. What is the ratio of the Aid flow from UN agencies (US$) of 2010 in Sub-Saharan Africa (developing only) to that in World?
Offer a terse response. 0.25. What is the ratio of the Aid flow from UN agencies (US$) in 2011 in Sub-Saharan Africa (developing only) to that in World?
Make the answer very short. 0.23. What is the ratio of the Aid flow from UN agencies (US$) in 2012 in Sub-Saharan Africa (developing only) to that in World?
Provide a short and direct response. 0.23. What is the difference between the highest and the second highest Aid flow from UN agencies (US$) in 2009?
Your answer should be very brief. 0. What is the difference between the highest and the second highest Aid flow from UN agencies (US$) of 2010?
Your answer should be very brief. 0. What is the difference between the highest and the second highest Aid flow from UN agencies (US$) in 2011?
Your answer should be compact. 6.70e+05. What is the difference between the highest and the second highest Aid flow from UN agencies (US$) in 2012?
Ensure brevity in your answer.  7.20e+05. What is the difference between the highest and the lowest Aid flow from UN agencies (US$) of 2009?
Offer a terse response. 4.16e+08. What is the difference between the highest and the lowest Aid flow from UN agencies (US$) of 2010?
Offer a very short reply. 3.41e+08. What is the difference between the highest and the lowest Aid flow from UN agencies (US$) in 2011?
Provide a short and direct response. 4.13e+08. What is the difference between the highest and the lowest Aid flow from UN agencies (US$) in 2012?
Make the answer very short. 3.59e+08. 